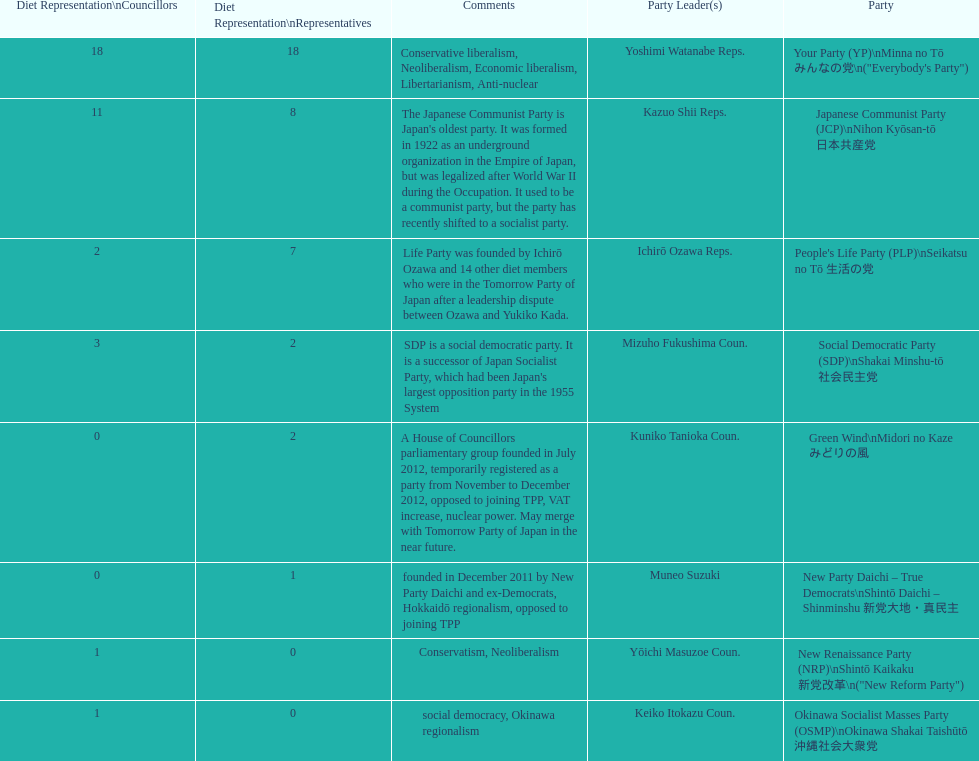According to this table, which party is japan's oldest political party? Japanese Communist Party (JCP) Nihon Kyōsan-tō 日本共産党. 